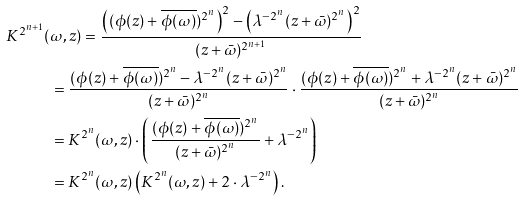Convert formula to latex. <formula><loc_0><loc_0><loc_500><loc_500>K ^ { 2 ^ { n + 1 } } ( & \omega , z ) = \frac { \left ( ( \phi ( z ) + \overline { \phi ( \omega ) } ) ^ { 2 ^ { n } } \right ) ^ { 2 } - \left ( \lambda ^ { - 2 ^ { n } } ( z + \bar { \omega } ) ^ { 2 ^ { n } } \right ) ^ { 2 } } { ( z + \bar { \omega } ) ^ { 2 ^ { n + 1 } } } \\ & = \frac { ( \phi ( z ) + \overline { \phi ( \omega ) } ) ^ { 2 ^ { n } } - \lambda ^ { - 2 ^ { n } } ( z + \bar { \omega } ) ^ { 2 ^ { n } } } { ( z + \bar { \omega } ) ^ { 2 ^ { n } } } \cdot \frac { ( \phi ( z ) + \overline { \phi ( \omega ) } ) ^ { 2 ^ { n } } + \lambda ^ { - 2 ^ { n } } ( z + \bar { \omega } ) ^ { 2 ^ { n } } } { ( z + \bar { \omega } ) ^ { 2 ^ { n } } } \\ & = K ^ { 2 ^ { n } } ( \omega , z ) \cdot \left ( \frac { ( \phi ( z ) + \overline { \phi ( \omega ) } ) ^ { 2 ^ { n } } } { ( z + \bar { \omega } ) ^ { 2 ^ { n } } } + \lambda ^ { - 2 ^ { n } } \right ) \\ & = K ^ { 2 ^ { n } } ( \omega , z ) \left ( K ^ { 2 ^ { n } } ( \omega , z ) + 2 \cdot \lambda ^ { - 2 ^ { n } } \right ) .</formula> 